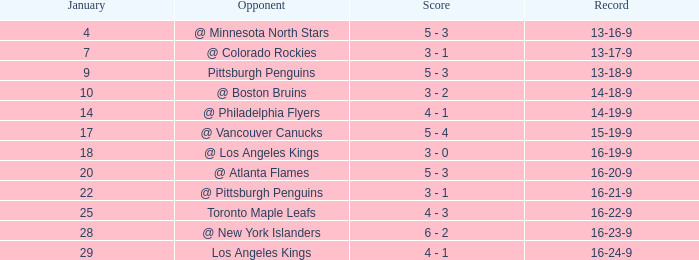What was the record after the game before Jan 7? 13-16-9. 